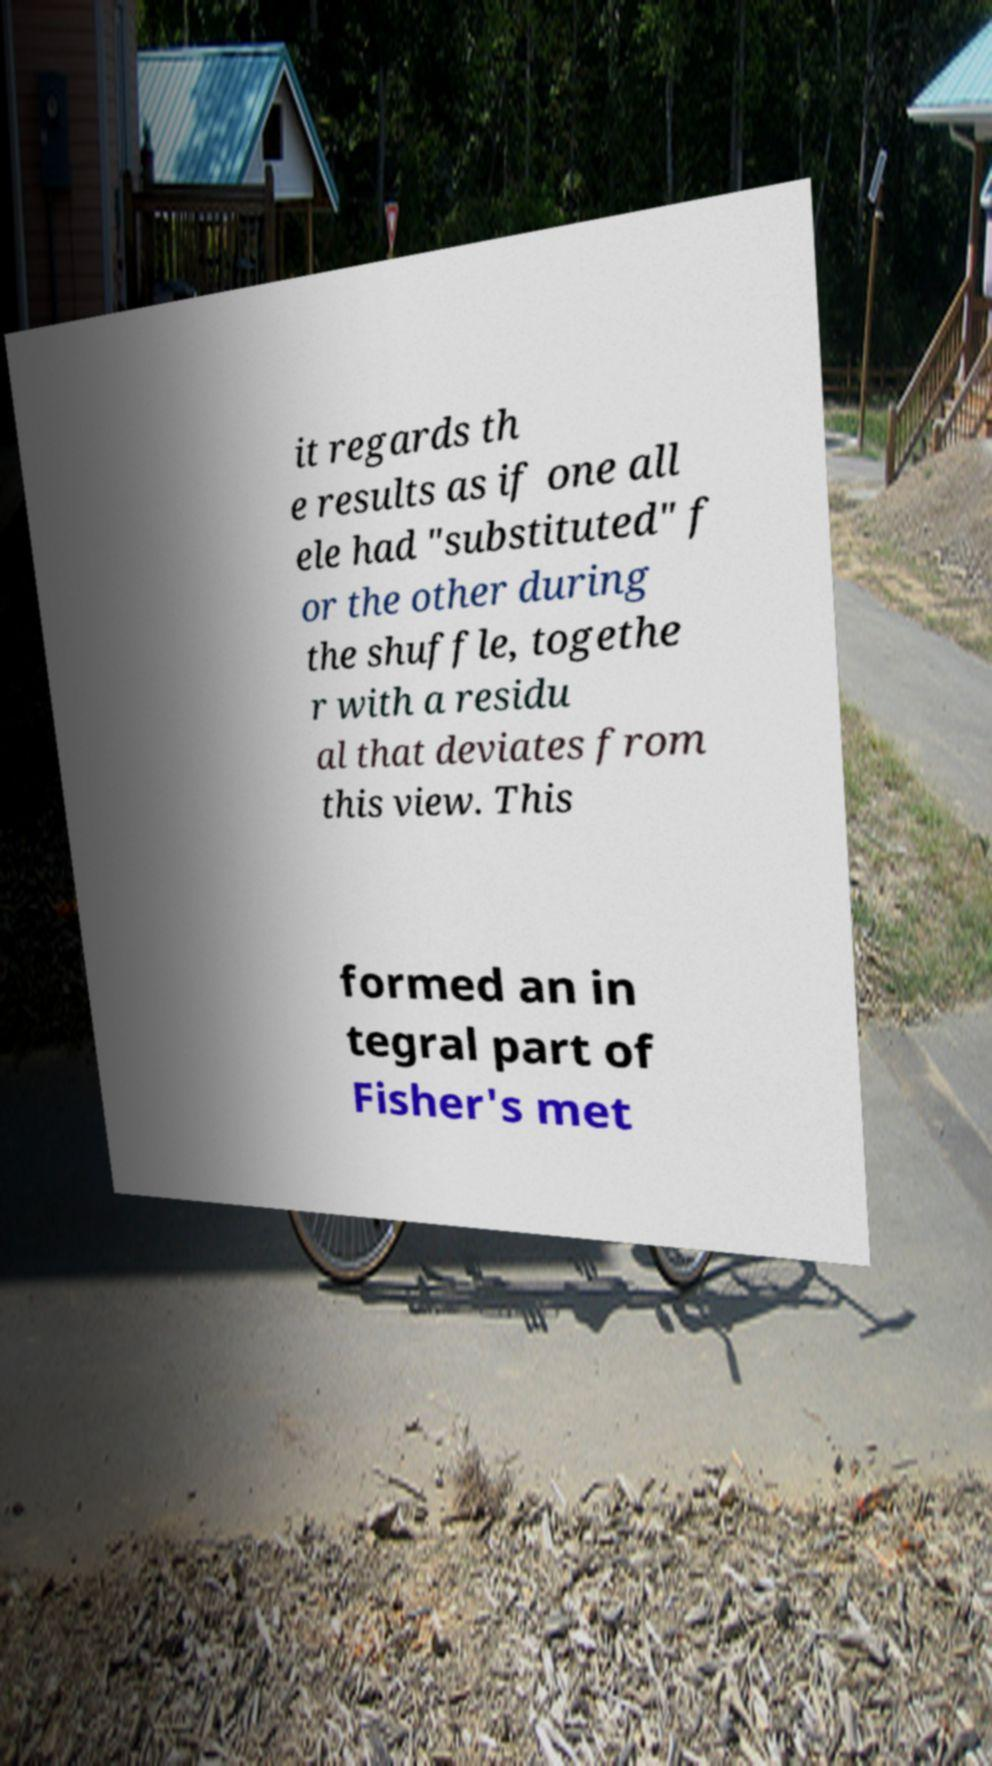Please read and relay the text visible in this image. What does it say? it regards th e results as if one all ele had "substituted" f or the other during the shuffle, togethe r with a residu al that deviates from this view. This formed an in tegral part of Fisher's met 